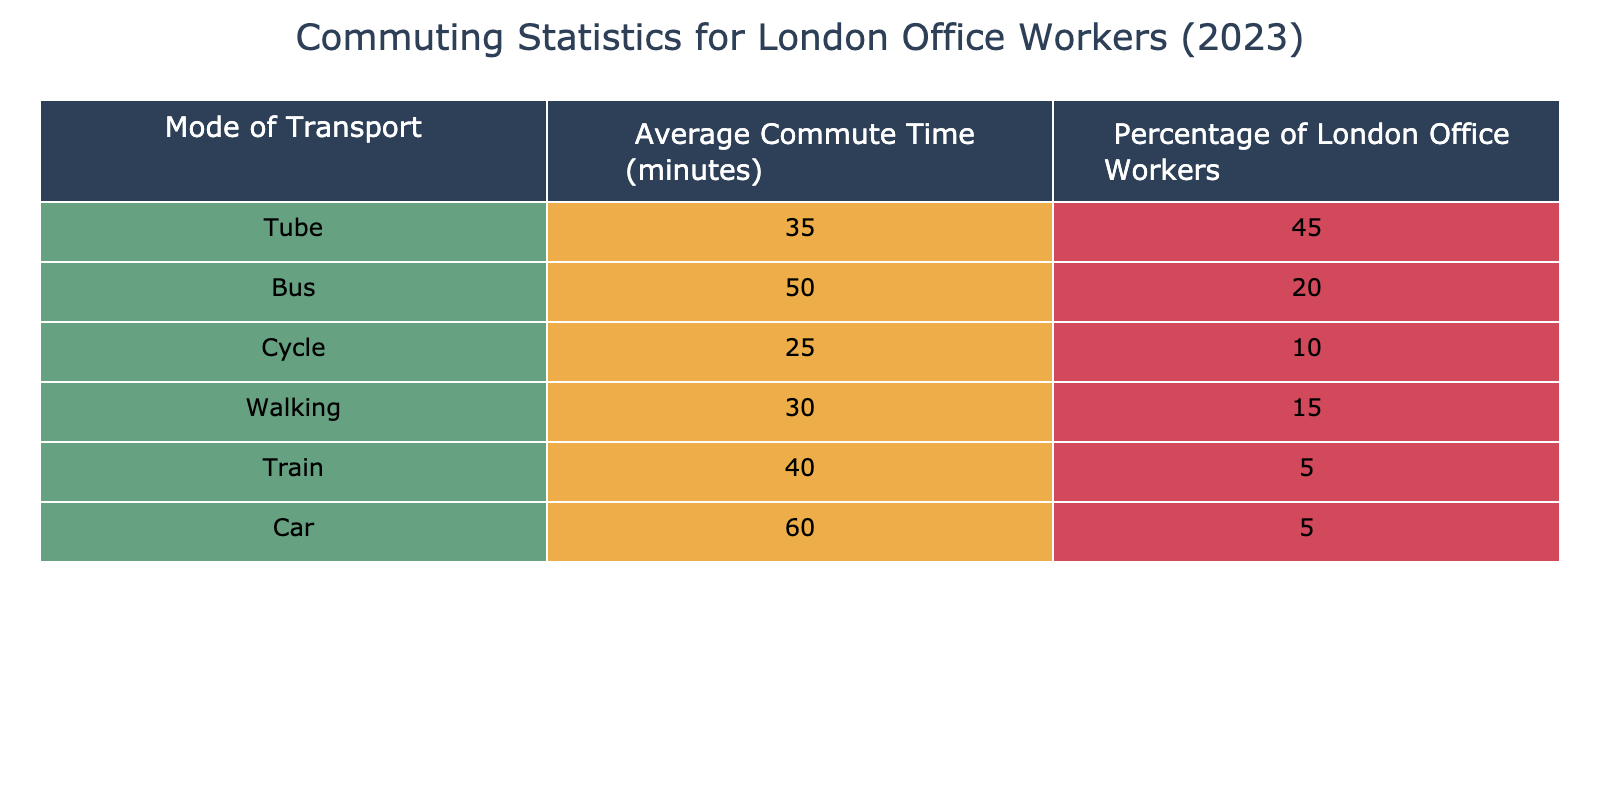What is the average commute time for Tube users? The table indicates that the average commute time for users of the Tube is listed under the "Average Commute Time (minutes)" column for that mode of transport. Specifically, it shows 35 minutes.
Answer: 35 minutes What percentage of London office workers commute by bus? Looking at the "Percentage of London Office Workers" column, the corresponding value for the bus is 20 percent.
Answer: 20 percent Which mode of transport has the shortest average commute time and what is that time? To find the mode of transport with the shortest commute time, we examine the "Average Commute Time (minutes)" column. The shortest time is 25 minutes for cycling, which is listed in the table.
Answer: Cycling, 25 minutes Is the average commute time for the car longer than that for the train? The average commute time for car users is 60 minutes, while for train users it is 40 minutes. Since 60 is greater than 40, the statement is true.
Answer: Yes What is the combined percentage of office workers who commute by Tube and Train? We add the percentages of Tube (45%) and Train (5%) users, which equals 50% (45 + 5 = 50). This represents the total percentage of office workers using these two modes combined.
Answer: 50 percent Which mode of transport has the highest average commute time? By looking at the "Average Commute Time (minutes)" column, the highest value of 60 minutes corresponds to car users, making it the mode with the longest average commuting time.
Answer: Car, 60 minutes What is the average commute time for all modes of transport combined? To find the average, we first sum the average commute times: (35 + 50 + 25 + 30 + 40 + 60) = 240 minutes. Then we divide by the number of modes, which is 6. Thus, 240/6 = 40 minutes.
Answer: 40 minutes Is walking a more popular commuting method than cycling among London office workers? We compare the percentages: cycling is at 10% and walking at 15%. Since 15% is greater than 10%, walking is indeed more popular than cycling.
Answer: Yes What is the difference in average commute time between the bus and walking? The average commute time for the bus is 50 minutes and for walking is 30 minutes. To find the difference, we subtract: 50 - 30 = 20 minutes.
Answer: 20 minutes 